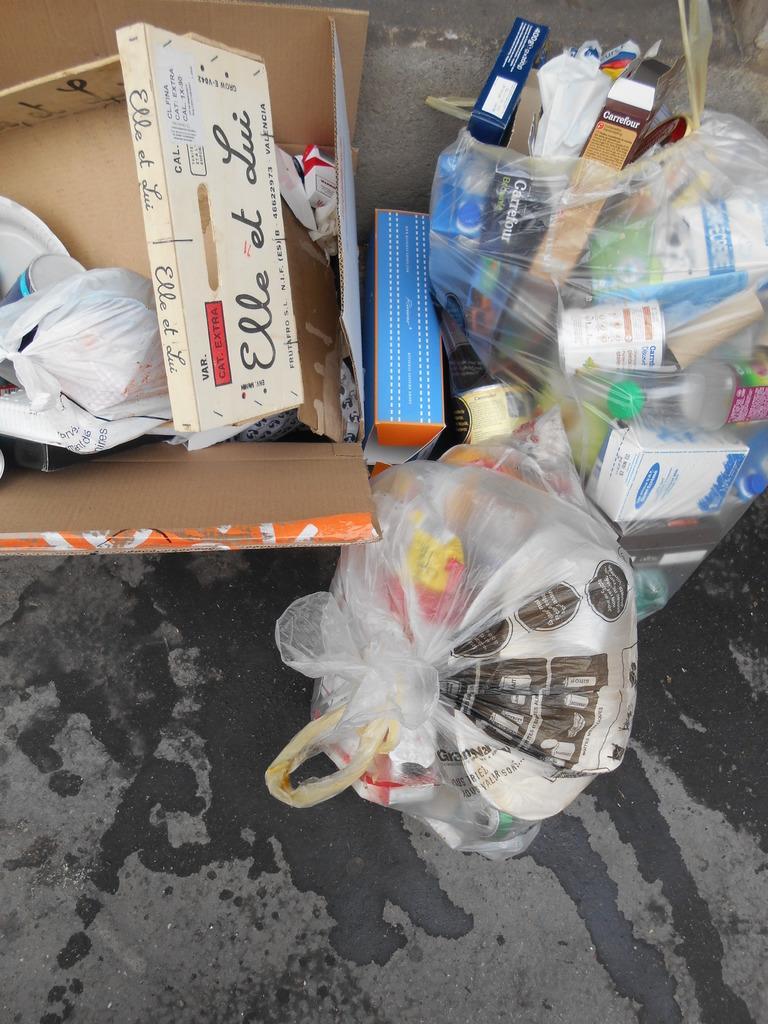Describe this image in one or two sentences. In this picture I can observe two plastic covers. On the left side I can observe brown color box. These covers are placed on the road. There is some water on the road. 